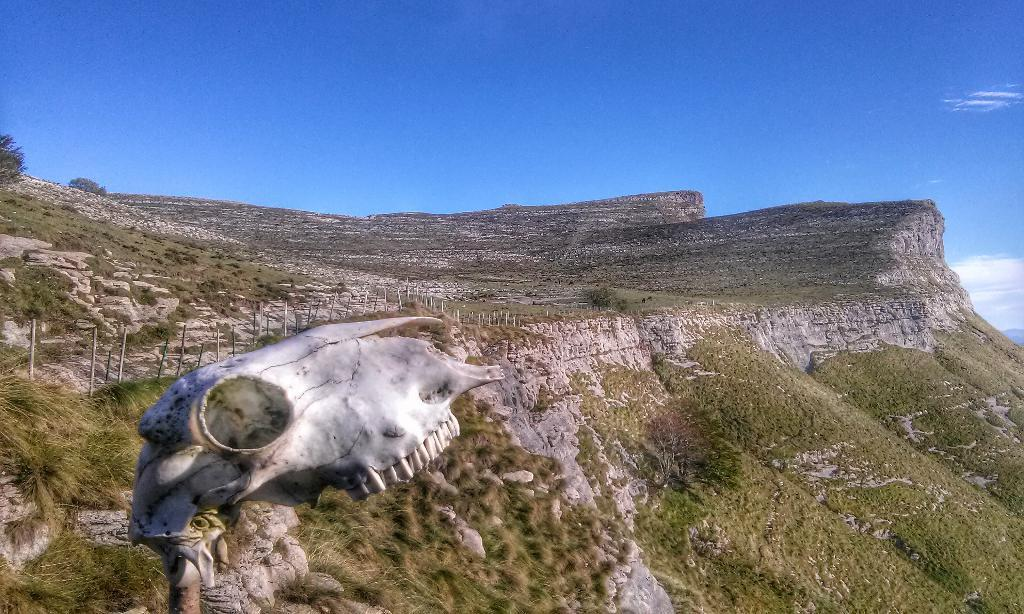What type of landscape can be seen in the image? There is a hill with greenery in the image. What other object is located near the hill? There is a sculpture beside the hill. What is used to enclose or separate areas in the image? There is some fencing beside the sculpture. What type of vase is placed on the hill in the image? There is no vase present on the hill in the image. How does the coil help the sculpture in the image? There is no coil mentioned in the image, and therefore it cannot help the sculpture. 